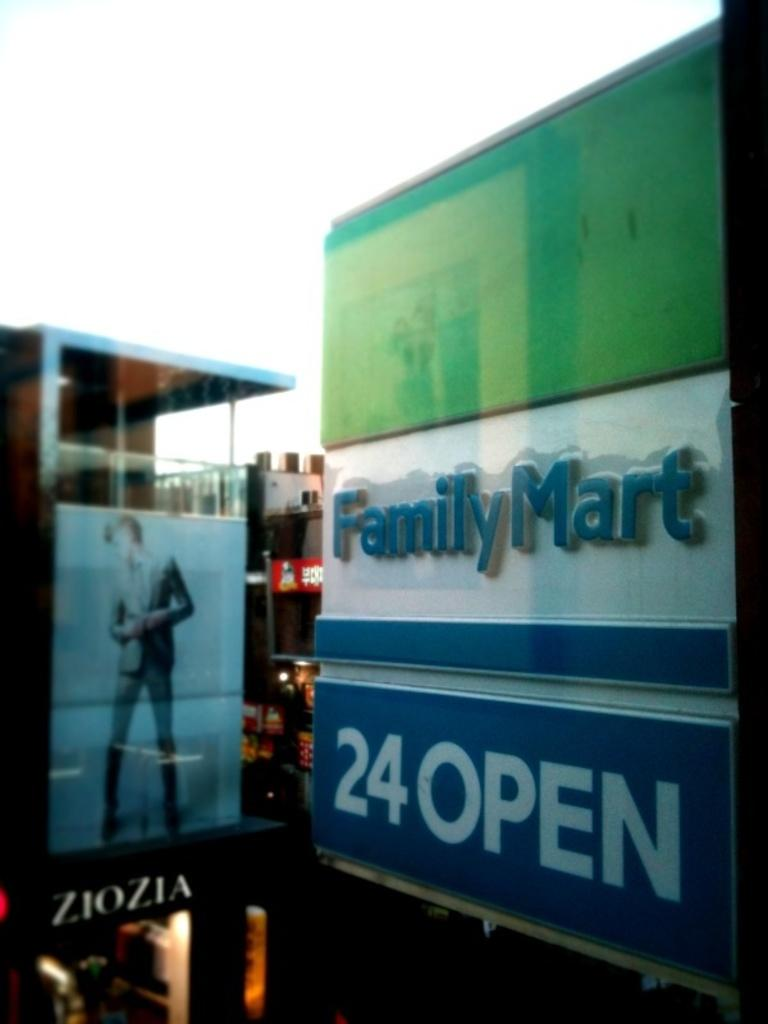<image>
Describe the image concisely. A sign for Family Mart advertises that it is open twenty four hours a day. 